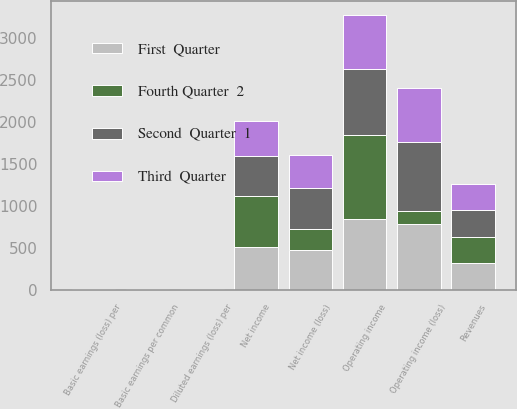Convert chart. <chart><loc_0><loc_0><loc_500><loc_500><stacked_bar_chart><ecel><fcel>Revenues<fcel>Operating income (loss)<fcel>Net income (loss)<fcel>Basic earnings (loss) per<fcel>Diluted earnings (loss) per<fcel>Operating income<fcel>Net income<fcel>Basic earnings per common<nl><fcel>Second  Quarter  1<fcel>317<fcel>814<fcel>494<fcel>1.6<fcel>1.58<fcel>784<fcel>475<fcel>1.55<nl><fcel>First  Quarter<fcel>317<fcel>783<fcel>479<fcel>1.55<fcel>1.54<fcel>839<fcel>511<fcel>1.67<nl><fcel>Third  Quarter<fcel>317<fcel>641<fcel>393<fcel>1.27<fcel>1.26<fcel>641<fcel>420<fcel>1.37<nl><fcel>Fourth Quarter  2<fcel>317<fcel>163<fcel>241<fcel>0.78<fcel>0.78<fcel>1012<fcel>610<fcel>1.98<nl></chart> 